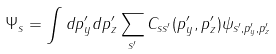Convert formula to latex. <formula><loc_0><loc_0><loc_500><loc_500>\Psi _ { s } = \int d p _ { y } ^ { \prime } d p _ { z } ^ { \prime } \sum _ { s ^ { \prime } } C _ { s s ^ { \prime } } ( p _ { y } ^ { \prime } , p _ { z } ^ { \prime } ) \psi _ { s ^ { \prime } , p _ { y } ^ { \prime } , p _ { z } ^ { \prime } }</formula> 